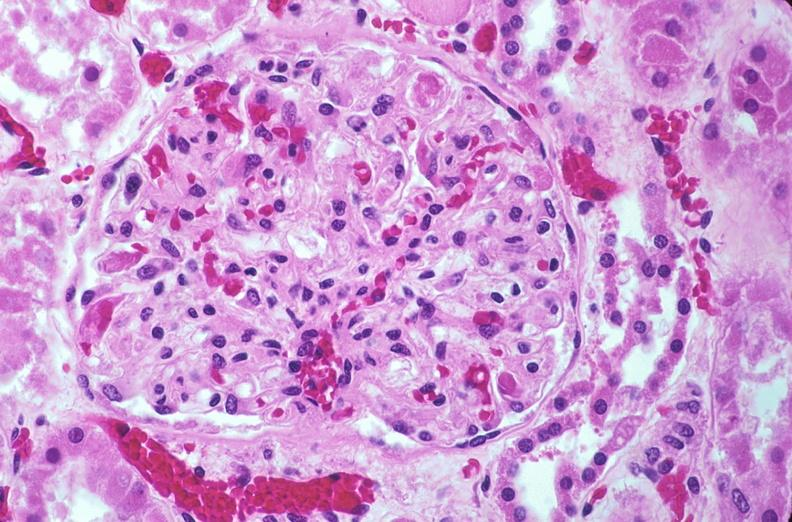does this image show kidney, microthrombi, disseminated intravascular coagulation?
Answer the question using a single word or phrase. Yes 